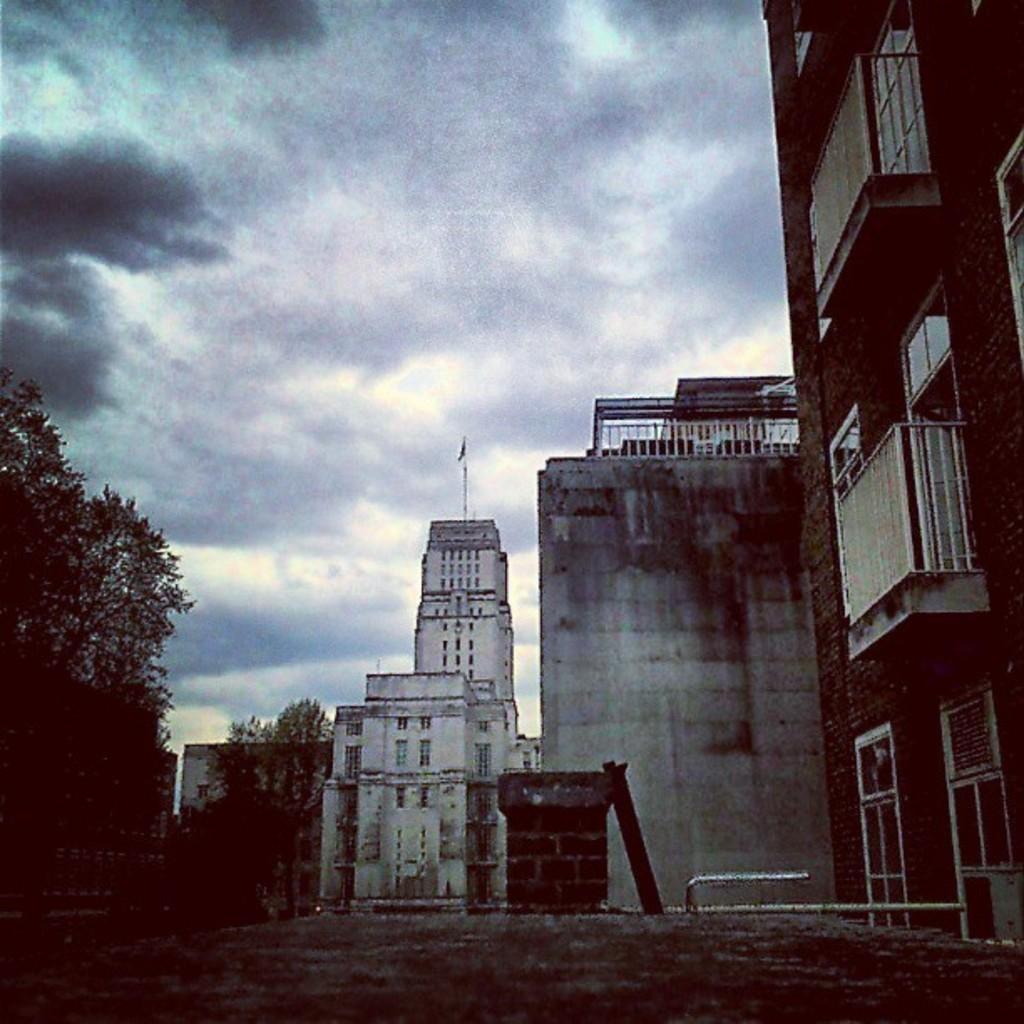In one or two sentences, can you explain what this image depicts? In this picture we can see road, buildings, trees and rods. In the background of the image we can see the sky with clouds. 